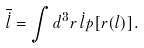Convert formula to latex. <formula><loc_0><loc_0><loc_500><loc_500>\overline { \dot { l } } = \int d ^ { 3 } { r } \, { \dot { l } } p [ { r } ( l ) ] .</formula> 